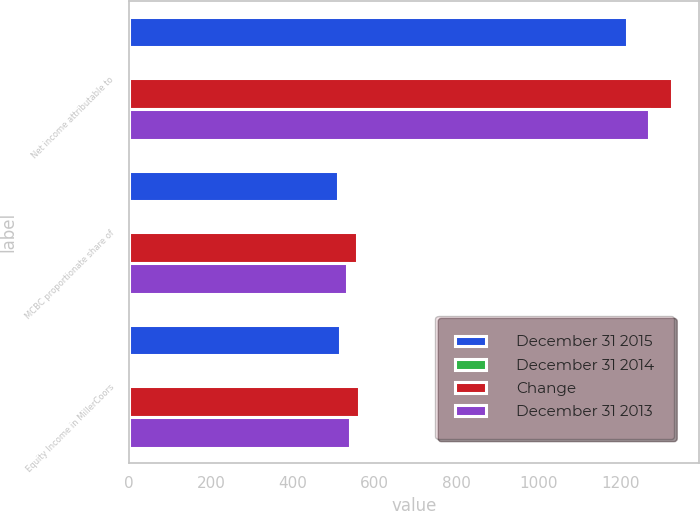<chart> <loc_0><loc_0><loc_500><loc_500><stacked_bar_chart><ecel><fcel>Net income attributable to<fcel>MCBC proportionate share of<fcel>Equity Income in MillerCoors<nl><fcel>December 31 2015<fcel>1217.8<fcel>511.5<fcel>516.3<nl><fcel>December 31 2014<fcel>8.2<fcel>8.2<fcel>8.1<nl><fcel>Change<fcel>1326.2<fcel>557<fcel>561.8<nl><fcel>December 31 2013<fcel>1270.5<fcel>533.6<fcel>539<nl></chart> 